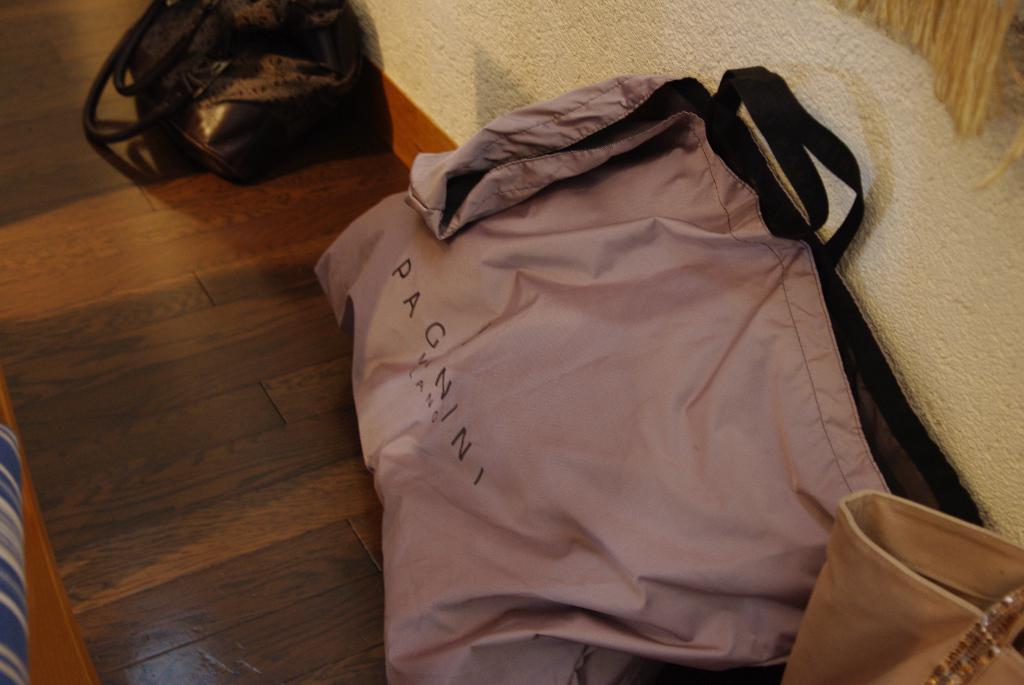How many bags can be seen in the image? There are three bags in the image. What is the color of the top bag? The top bag is black. What is the color of the other two bags? The other two bags are peach-colored. Is there any text on any of the bags? Yes, "PAGANINI" is written on one of the bags. How many verses are written in ink on the bags? There are no verses written in ink on the bags; only the text "PAGANINI" is present on one of the bags. 